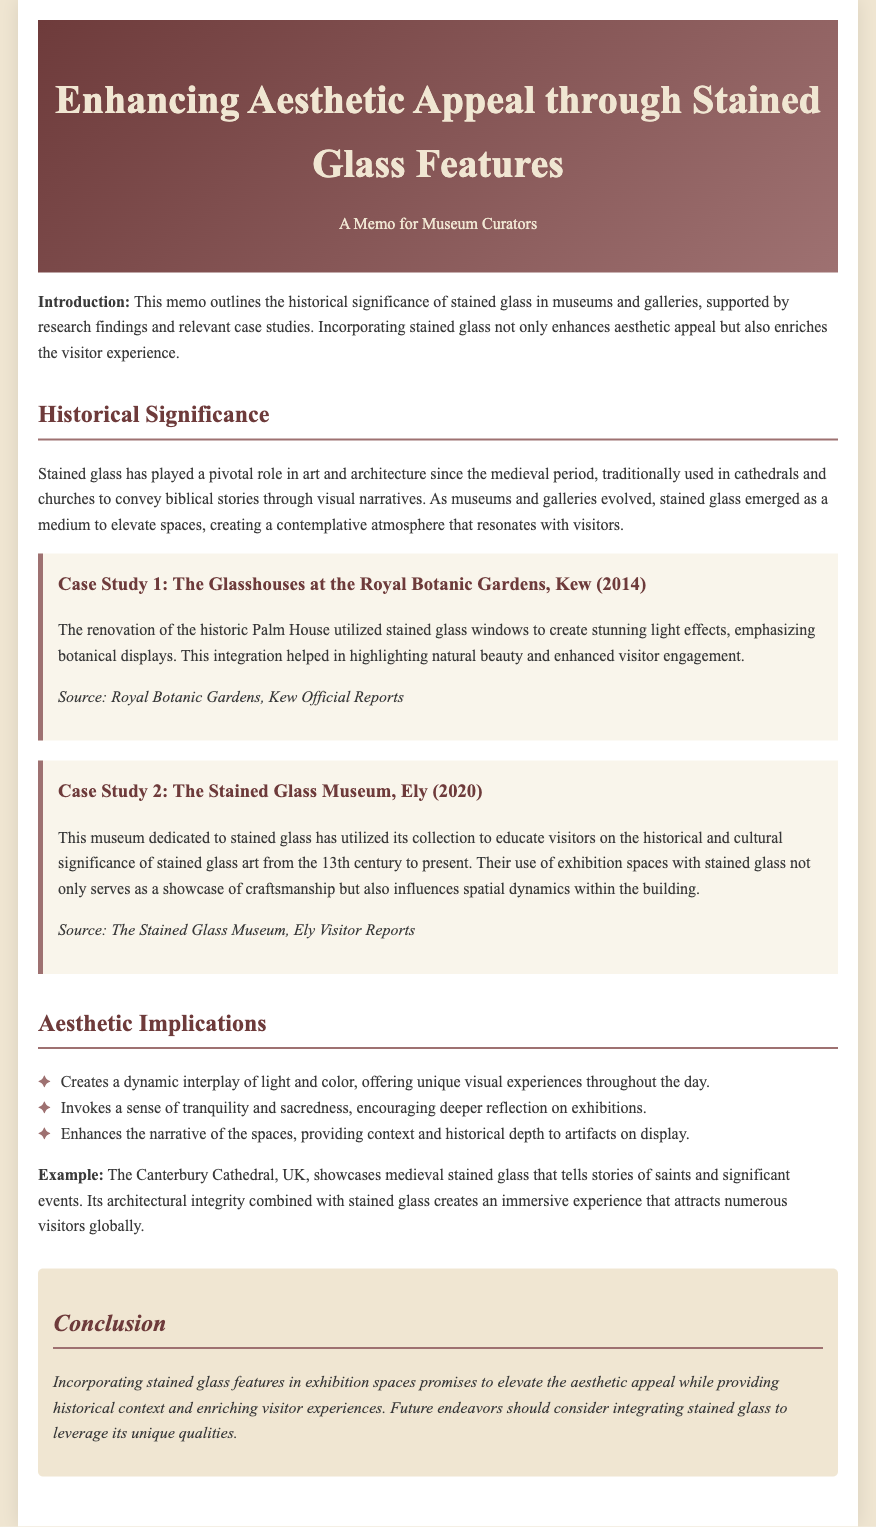What is the title of the memo? The title of the memo is stated clearly at the top of the document.
Answer: Enhancing Aesthetic Appeal through Stained Glass Features What year was the renovation of the Glasshouses at the Royal Botanic Gardens, Kew completed? The document mentions the year of the renovation in the case study section.
Answer: 2014 Which museum is dedicated to stained glass? The document provides the name of the museum in the description of the second case study.
Answer: The Stained Glass Museum, Ely What is one aesthetic implication of incorporating stained glass? The memo lists aesthetic implications under a specific section, providing benefits of stained glass features.
Answer: Creates a dynamic interplay of light and color What does stained glass in Canterbury Cathedral tell stories of? The document mentions what the stained glass represents in the example provided.
Answer: Saints and significant events How does stained glass affect visitor engagement according to the case studies? The memo explains the interaction between stained glass features and visitor experiences in the case studies.
Answer: Enhances visitor engagement What cultural period does the Stained Glass Museum cover? The document mentions the range of time periods that the museum's collection educates visitors about.
Answer: 13th century to present What atmosphere does stained glass create in exhibition spaces? The memo discusses the emotional and reflective qualities brought by stained glass in galleries and museums.
Answer: Tranquility and sacredness 